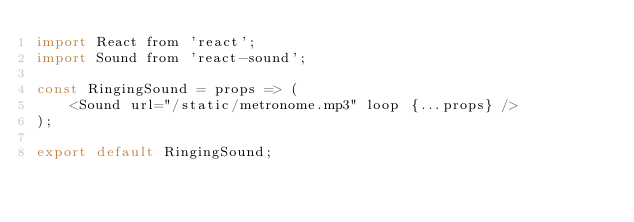Convert code to text. <code><loc_0><loc_0><loc_500><loc_500><_JavaScript_>import React from 'react';
import Sound from 'react-sound';

const RingingSound = props => (
    <Sound url="/static/metronome.mp3" loop {...props} />
);

export default RingingSound;
</code> 